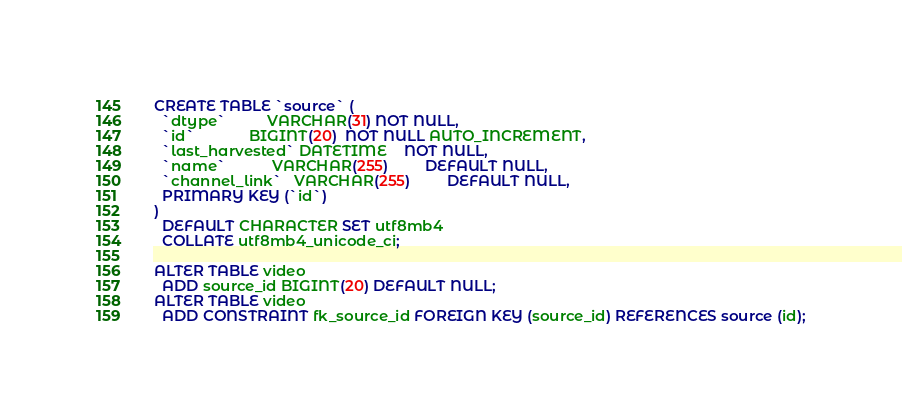Convert code to text. <code><loc_0><loc_0><loc_500><loc_500><_SQL_>CREATE TABLE `source` (
  `dtype`          VARCHAR(31) NOT NULL,
  `id`             BIGINT(20)  NOT NULL AUTO_INCREMENT,
  `last_harvested` DATETIME    NOT NULL,
  `name`           VARCHAR(255)         DEFAULT NULL,
  `channel_link`   VARCHAR(255)         DEFAULT NULL,
  PRIMARY KEY (`id`)
)
  DEFAULT CHARACTER SET utf8mb4
  COLLATE utf8mb4_unicode_ci;

ALTER TABLE video
  ADD source_id BIGINT(20) DEFAULT NULL;
ALTER TABLE video
  ADD CONSTRAINT fk_source_id FOREIGN KEY (source_id) REFERENCES source (id);

</code> 